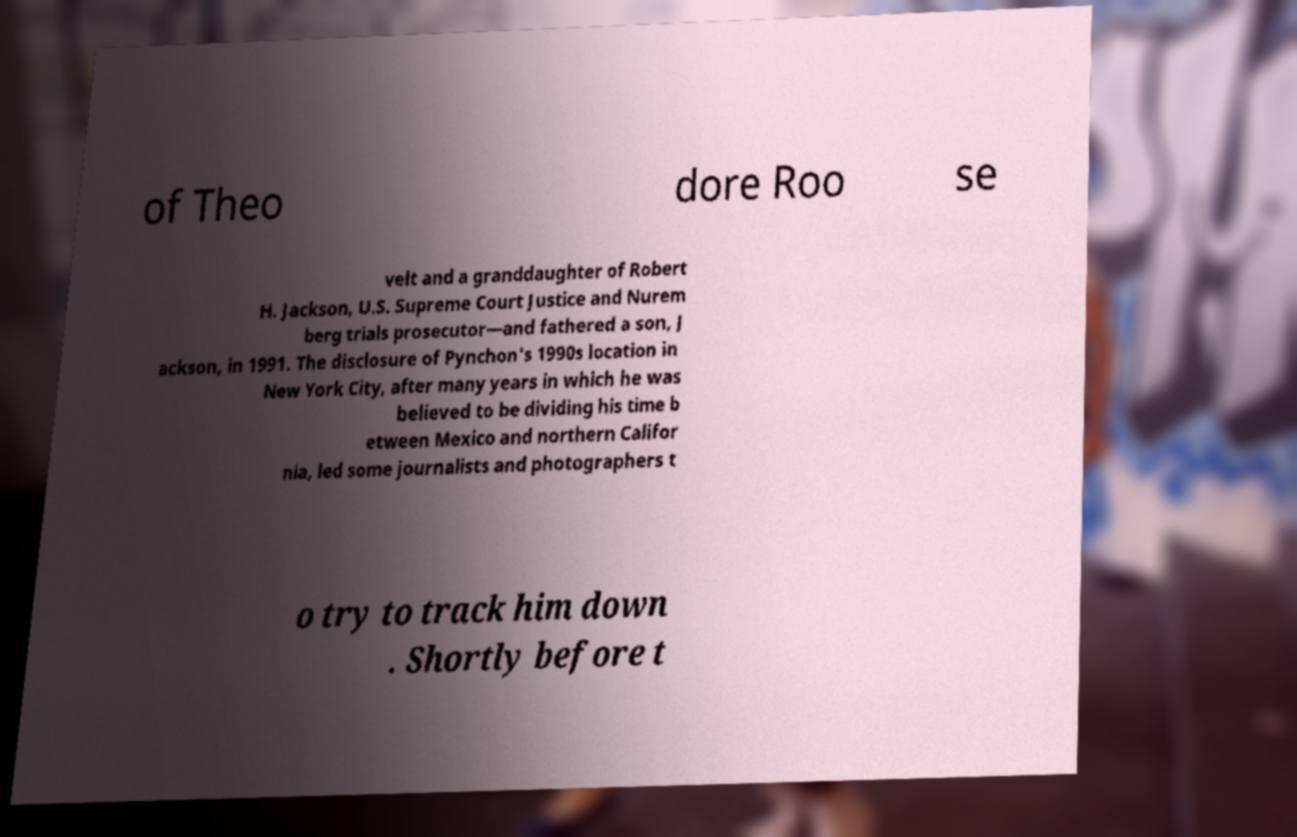There's text embedded in this image that I need extracted. Can you transcribe it verbatim? of Theo dore Roo se velt and a granddaughter of Robert H. Jackson, U.S. Supreme Court Justice and Nurem berg trials prosecutor—and fathered a son, J ackson, in 1991. The disclosure of Pynchon's 1990s location in New York City, after many years in which he was believed to be dividing his time b etween Mexico and northern Califor nia, led some journalists and photographers t o try to track him down . Shortly before t 